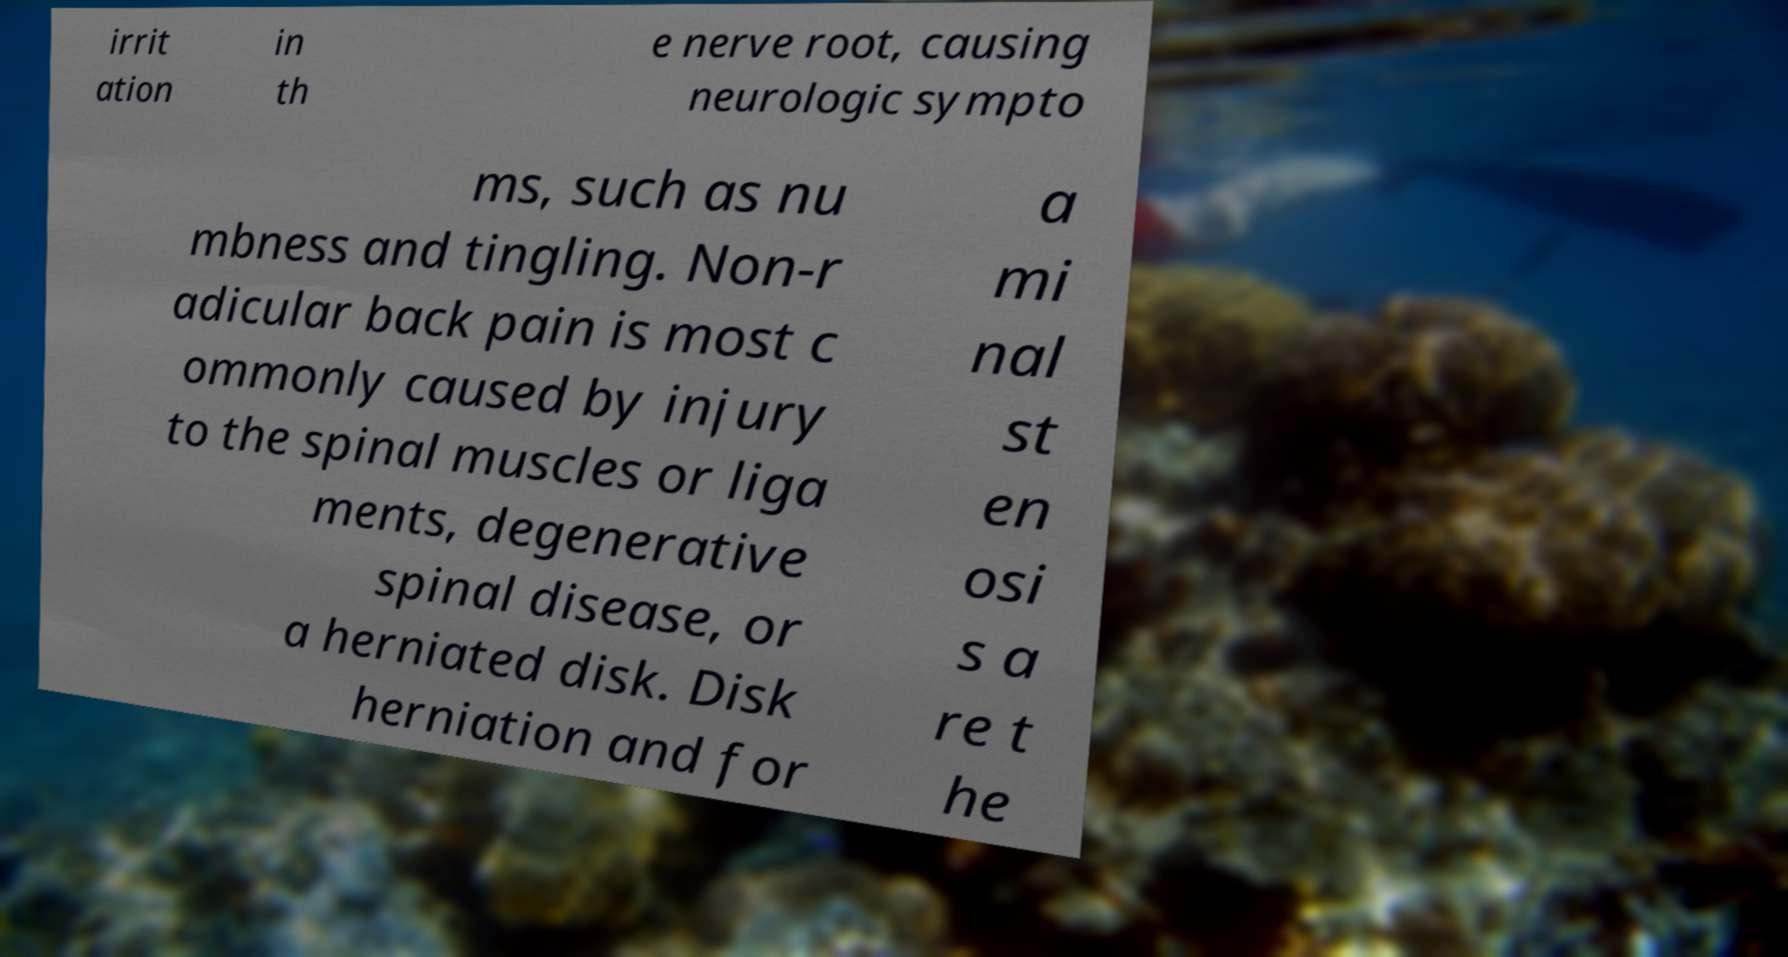I need the written content from this picture converted into text. Can you do that? irrit ation in th e nerve root, causing neurologic sympto ms, such as nu mbness and tingling. Non-r adicular back pain is most c ommonly caused by injury to the spinal muscles or liga ments, degenerative spinal disease, or a herniated disk. Disk herniation and for a mi nal st en osi s a re t he 